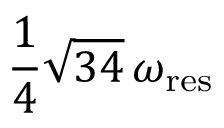Convert formula to latex. <formula><loc_0><loc_0><loc_500><loc_500>\frac { 1 } { 4 } \sqrt { 3 4 } \, \omega _ { r e s }</formula> 